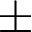Convert formula to latex. <formula><loc_0><loc_0><loc_500><loc_500>\pm</formula> 